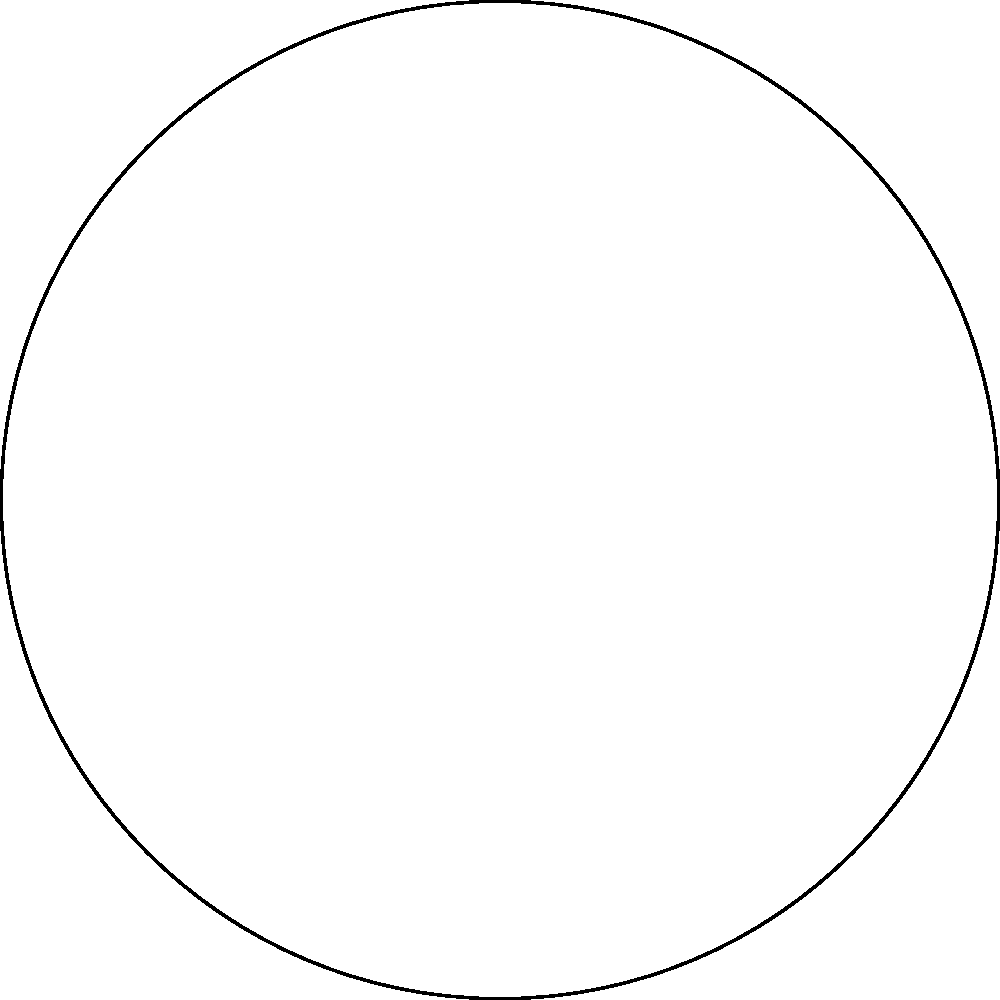You are photographing the circular arrangement of statues atop St. Peter's Basilica in the Vatican. The statues are equally spaced around the dome. If you're capturing the statue at $0°$ and want to photograph the statue directly opposite to it, at what angle should you position your camera? To solve this problem, let's follow these steps:

1. Understand the circular arrangement:
   - The statues are equally spaced around a full circle (360°).
   - There are 8 statues in total, as shown in the diagram.

2. Calculate the angle between each statue:
   - Angle between statues = 360° ÷ 8 = 45°

3. Identify the starting point:
   - The question states that you're starting at the statue at 0°.

4. Find the opposite statue:
   - The opposite statue would be exactly halfway around the circle.
   - Half of a full circle is 180°.

5. Verify the answer:
   - Starting from 0° and moving 180° clockwise brings us to the statue directly opposite.
   - This can also be confirmed by counting 4 positions clockwise from the 0° statue.

Therefore, to photograph the statue directly opposite to the one at 0°, you should position your camera at an angle of 180°.
Answer: 180° 